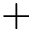<formula> <loc_0><loc_0><loc_500><loc_500>+</formula> 